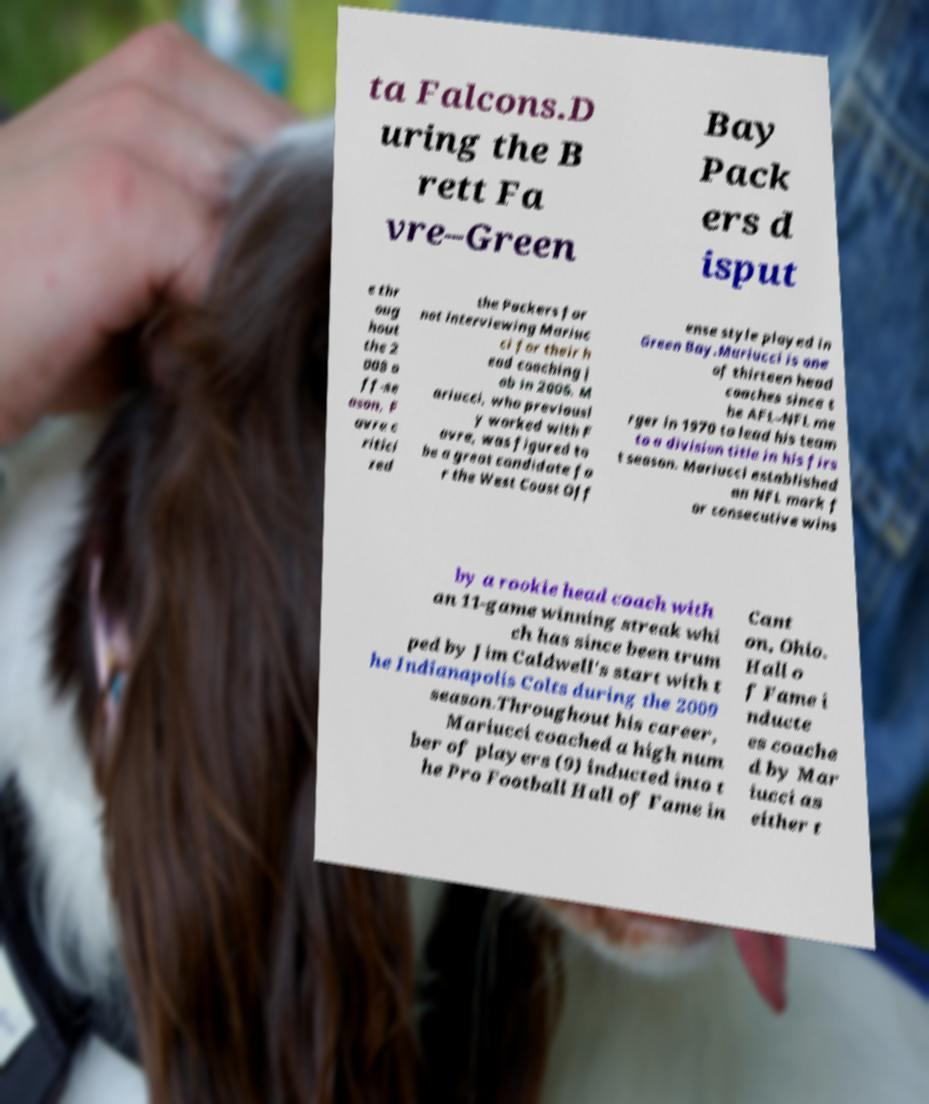For documentation purposes, I need the text within this image transcribed. Could you provide that? ta Falcons.D uring the B rett Fa vre–Green Bay Pack ers d isput e thr oug hout the 2 008 o ff-se ason, F avre c ritici zed the Packers for not interviewing Mariuc ci for their h ead coaching j ob in 2006. M ariucci, who previousl y worked with F avre, was figured to be a great candidate fo r the West Coast Off ense style played in Green Bay.Mariucci is one of thirteen head coaches since t he AFL–NFL me rger in 1970 to lead his team to a division title in his firs t season. Mariucci established an NFL mark f or consecutive wins by a rookie head coach with an 11-game winning streak whi ch has since been trum ped by Jim Caldwell's start with t he Indianapolis Colts during the 2009 season.Throughout his career, Mariucci coached a high num ber of players (9) inducted into t he Pro Football Hall of Fame in Cant on, Ohio. Hall o f Fame i nducte es coache d by Mar iucci as either t 